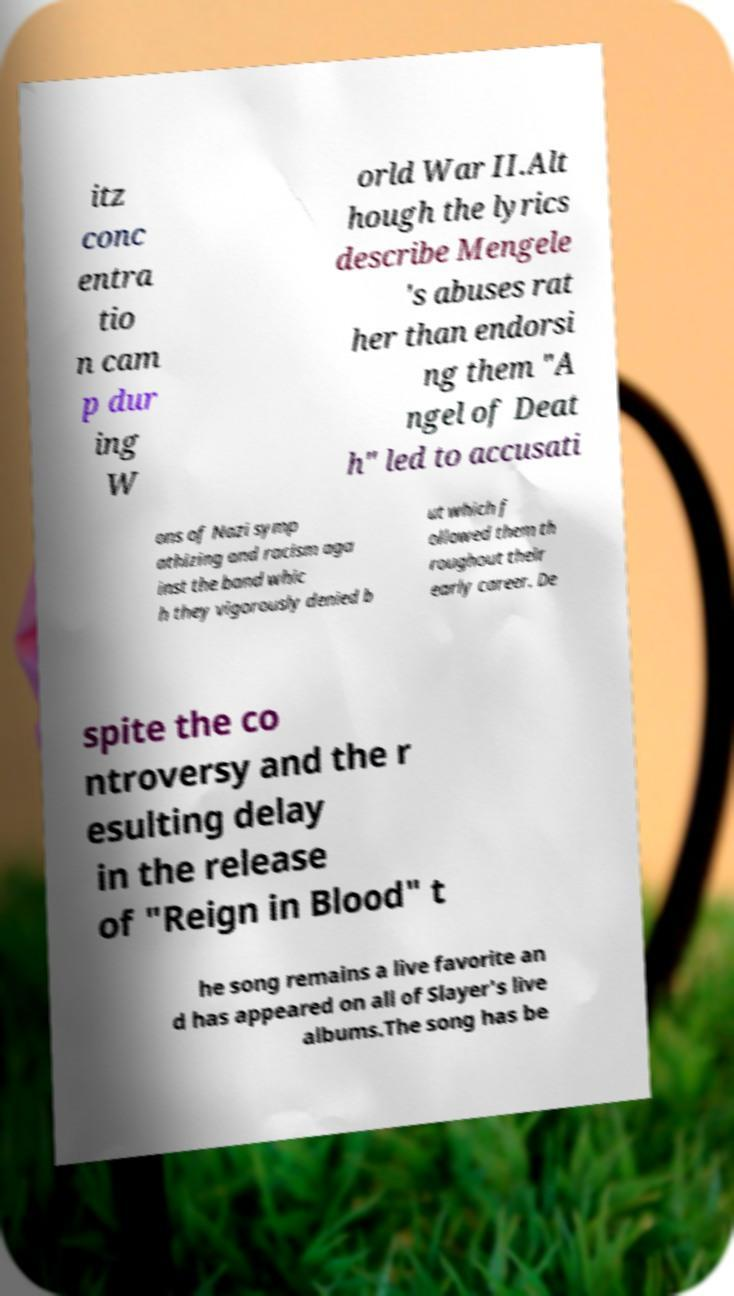Can you accurately transcribe the text from the provided image for me? itz conc entra tio n cam p dur ing W orld War II.Alt hough the lyrics describe Mengele 's abuses rat her than endorsi ng them "A ngel of Deat h" led to accusati ons of Nazi symp athizing and racism aga inst the band whic h they vigorously denied b ut which f ollowed them th roughout their early career. De spite the co ntroversy and the r esulting delay in the release of "Reign in Blood" t he song remains a live favorite an d has appeared on all of Slayer's live albums.The song has be 